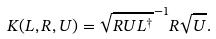Convert formula to latex. <formula><loc_0><loc_0><loc_500><loc_500>K ( L , R , U ) = \sqrt { R U L ^ { \dagger } } ^ { - 1 } R \sqrt { U } .</formula> 